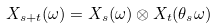<formula> <loc_0><loc_0><loc_500><loc_500>X _ { s + t } ( \omega ) = X _ { s } ( \omega ) \otimes X _ { t } ( \theta _ { s } \omega )</formula> 